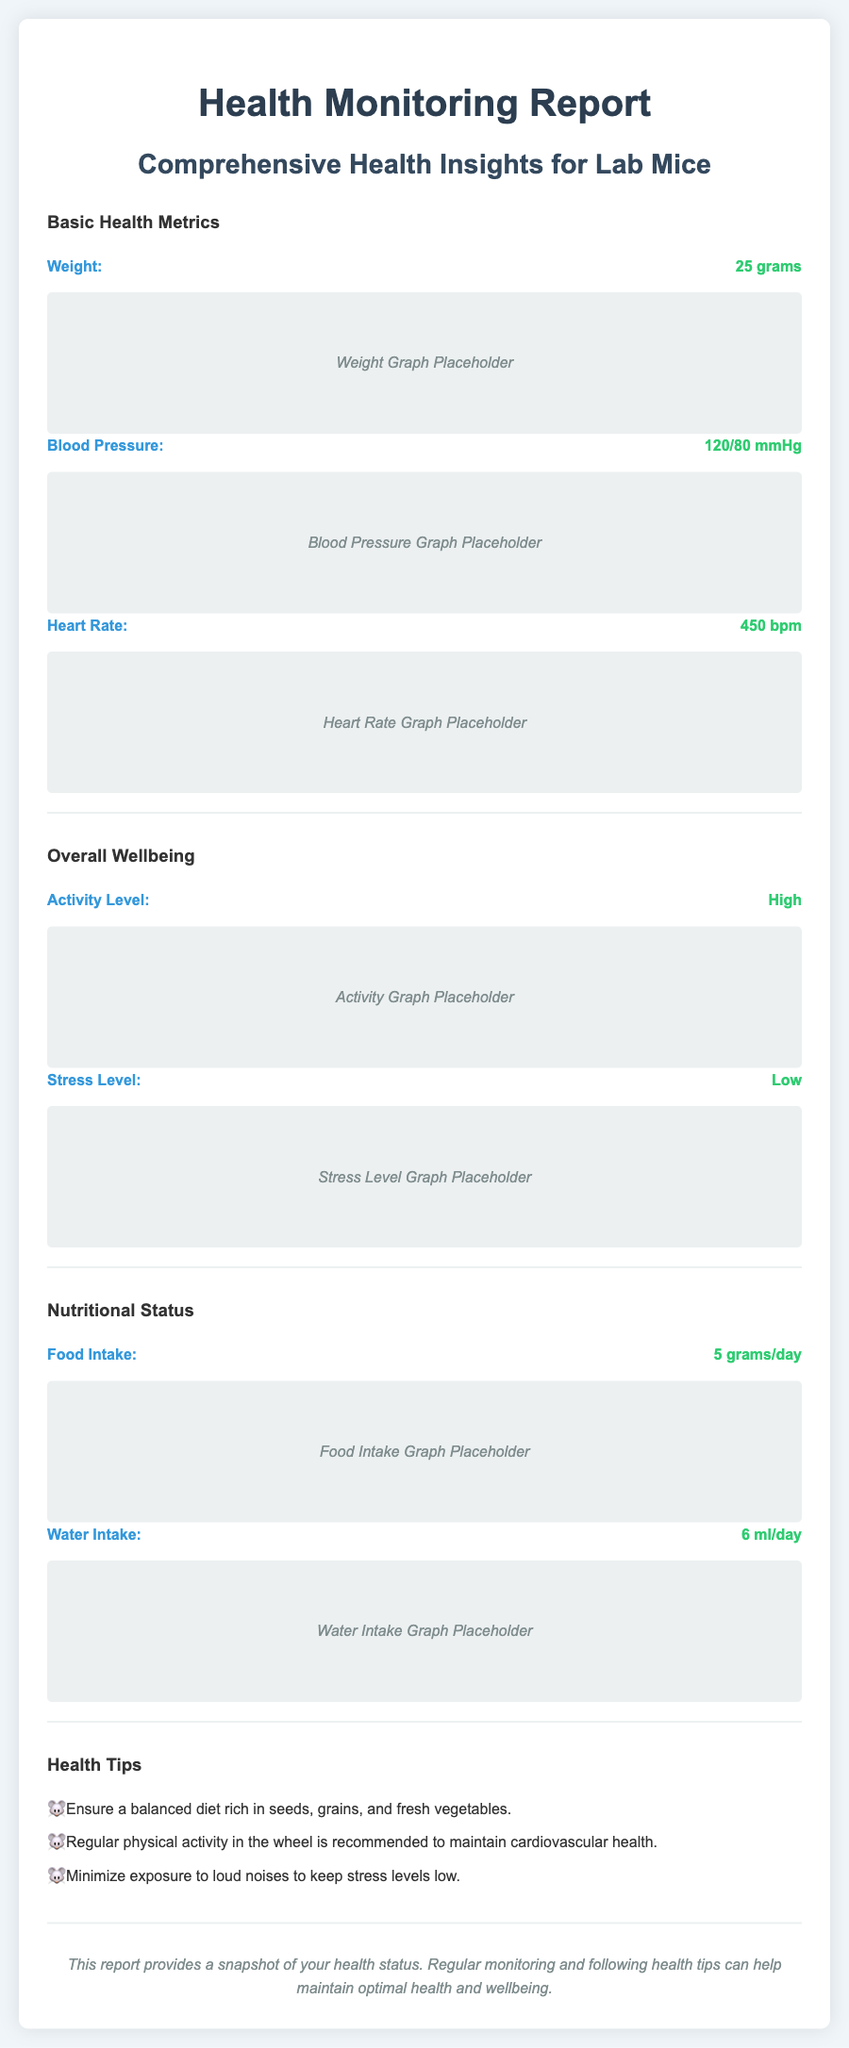What is the weight of the lab mouse? The weight is provided in the document under Basic Health Metrics.
Answer: 25 grams What is the blood pressure reading? The blood pressure is listed with its value in the Basic Health Metrics section.
Answer: 120/80 mmHg What is the heart rate of the lab mouse? The heart rate can be found in the Basic Health Metrics section of the report.
Answer: 450 bpm What is the activity level of the mouse? The activity level is mentioned in the Overall Wellbeing section.
Answer: High How much food does the lab mouse consume daily? The food intake value is stated in the Nutritional Status section.
Answer: 5 grams/day What is the stress level reported for the mouse? The stress level can be found in the Overall Wellbeing section of the report.
Answer: Low What health tip is provided regarding diet? The health tips section includes various guidelines.
Answer: Ensure a balanced diet rich in seeds, grains, and fresh vegetables Which health metric has a high value? The comparison of values leads to identifying the high metric.
Answer: Heart Rate What section follows the Overall Wellbeing? The structure of the document indicates the order of sections.
Answer: Nutritional Status 